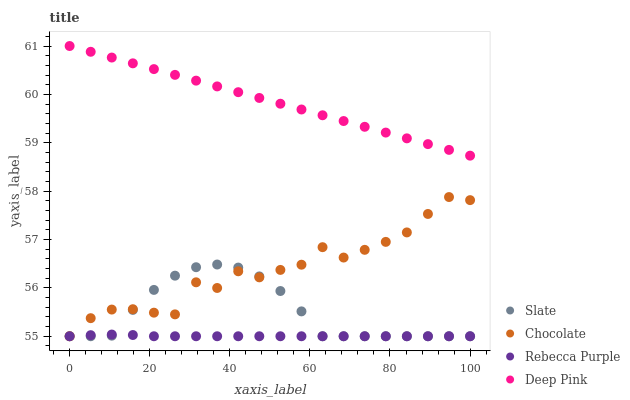Does Rebecca Purple have the minimum area under the curve?
Answer yes or no. Yes. Does Deep Pink have the maximum area under the curve?
Answer yes or no. Yes. Does Deep Pink have the minimum area under the curve?
Answer yes or no. No. Does Rebecca Purple have the maximum area under the curve?
Answer yes or no. No. Is Deep Pink the smoothest?
Answer yes or no. Yes. Is Chocolate the roughest?
Answer yes or no. Yes. Is Rebecca Purple the smoothest?
Answer yes or no. No. Is Rebecca Purple the roughest?
Answer yes or no. No. Does Slate have the lowest value?
Answer yes or no. Yes. Does Deep Pink have the lowest value?
Answer yes or no. No. Does Deep Pink have the highest value?
Answer yes or no. Yes. Does Rebecca Purple have the highest value?
Answer yes or no. No. Is Slate less than Deep Pink?
Answer yes or no. Yes. Is Deep Pink greater than Chocolate?
Answer yes or no. Yes. Does Chocolate intersect Slate?
Answer yes or no. Yes. Is Chocolate less than Slate?
Answer yes or no. No. Is Chocolate greater than Slate?
Answer yes or no. No. Does Slate intersect Deep Pink?
Answer yes or no. No. 